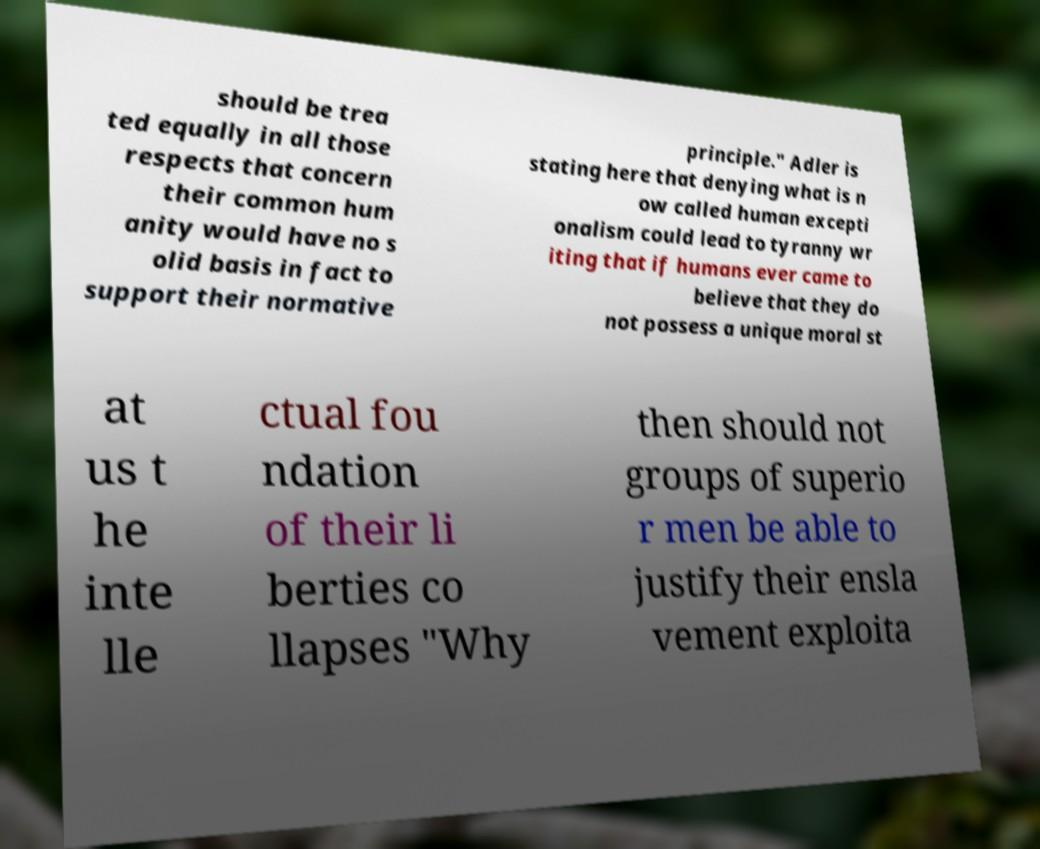Could you assist in decoding the text presented in this image and type it out clearly? should be trea ted equally in all those respects that concern their common hum anity would have no s olid basis in fact to support their normative principle." Adler is stating here that denying what is n ow called human excepti onalism could lead to tyranny wr iting that if humans ever came to believe that they do not possess a unique moral st at us t he inte lle ctual fou ndation of their li berties co llapses "Why then should not groups of superio r men be able to justify their ensla vement exploita 